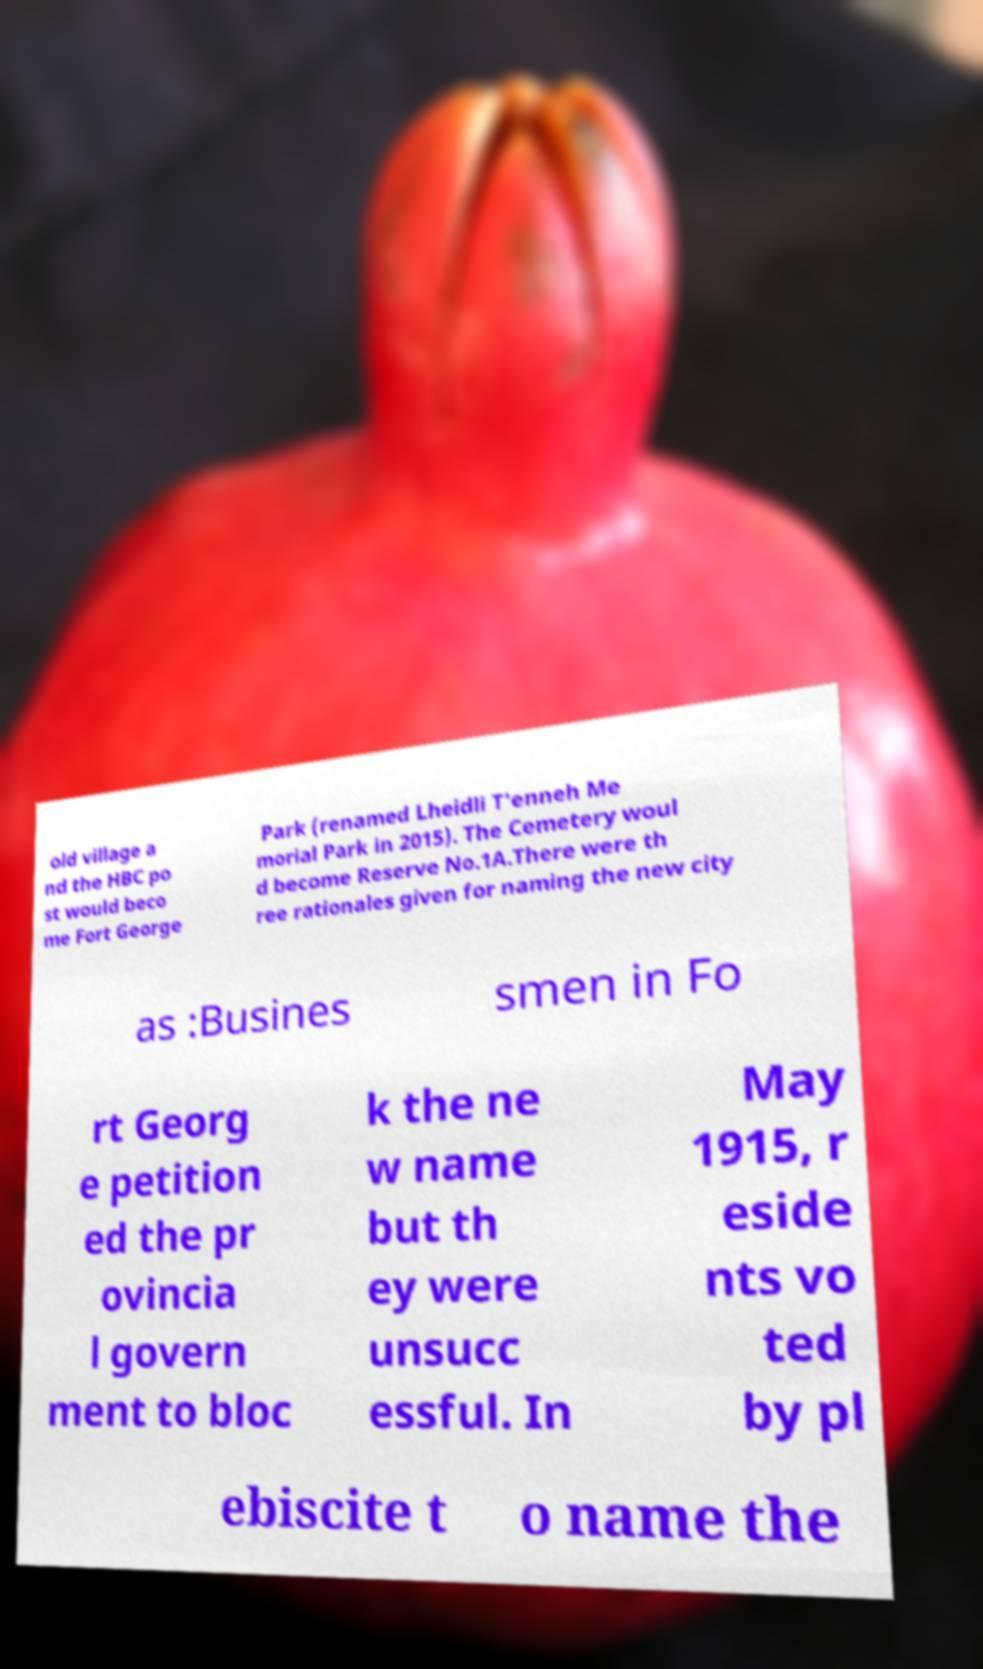Please read and relay the text visible in this image. What does it say? old village a nd the HBC po st would beco me Fort George Park (renamed Lheidli T'enneh Me morial Park in 2015). The Cemetery woul d become Reserve No.1A.There were th ree rationales given for naming the new city as :Busines smen in Fo rt Georg e petition ed the pr ovincia l govern ment to bloc k the ne w name but th ey were unsucc essful. In May 1915, r eside nts vo ted by pl ebiscite t o name the 